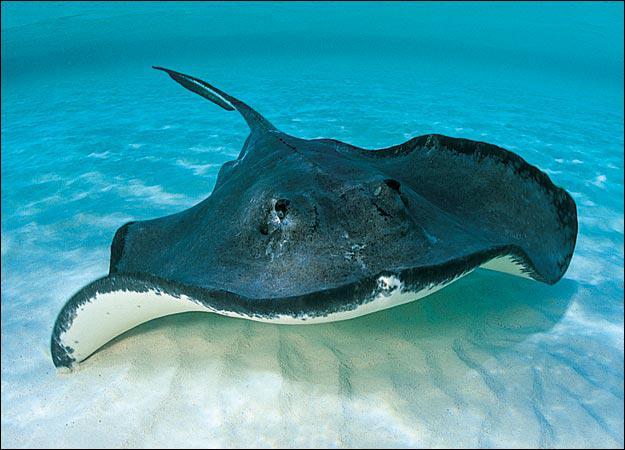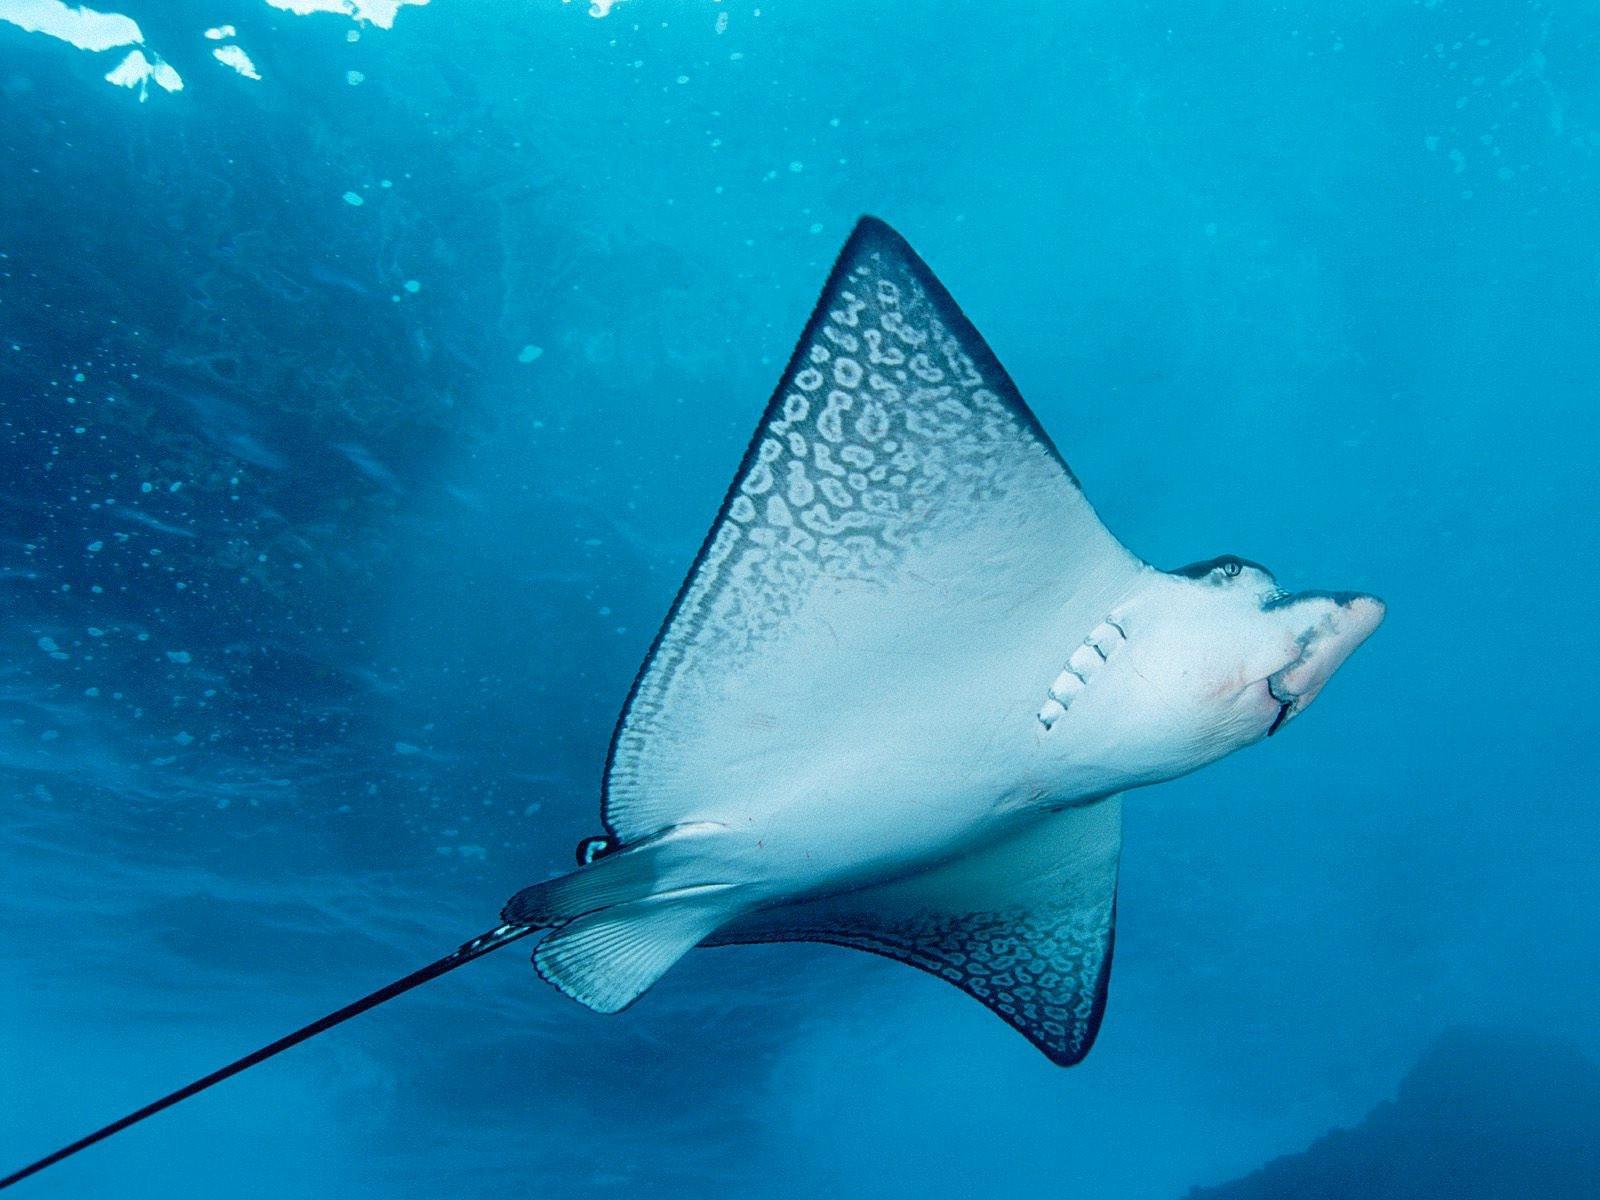The first image is the image on the left, the second image is the image on the right. Evaluate the accuracy of this statement regarding the images: "The creature in the image on the left appears to be smiling.". Is it true? Answer yes or no. No. 